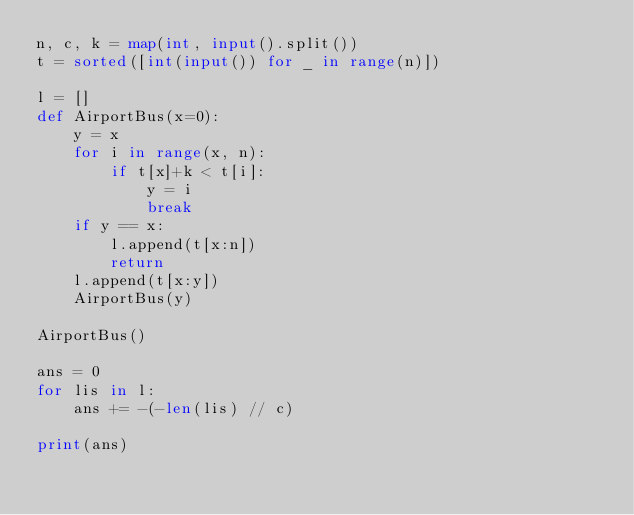<code> <loc_0><loc_0><loc_500><loc_500><_Python_>n, c, k = map(int, input().split())
t = sorted([int(input()) for _ in range(n)])

l = []
def AirportBus(x=0):
    y = x
    for i in range(x, n):
        if t[x]+k < t[i]:
            y = i
            break
    if y == x:
        l.append(t[x:n])
        return
    l.append(t[x:y])
    AirportBus(y)
    
AirportBus()

ans = 0
for lis in l:
    ans += -(-len(lis) // c)

print(ans)</code> 